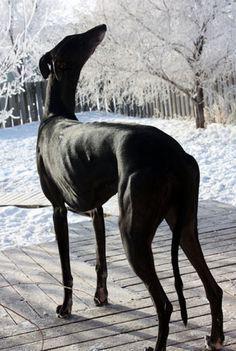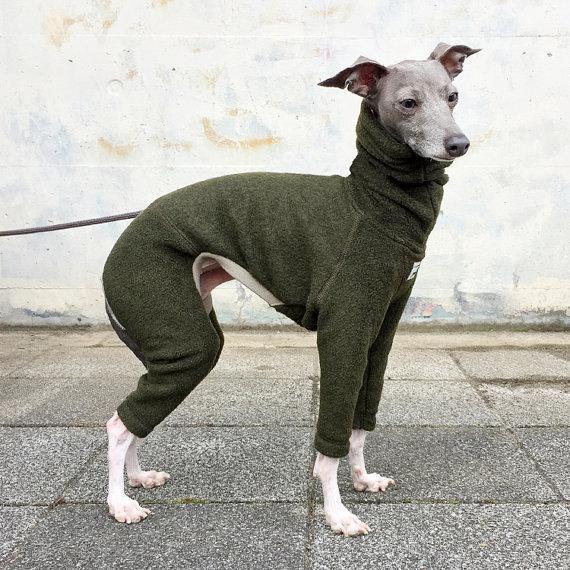The first image is the image on the left, the second image is the image on the right. Examine the images to the left and right. Is the description "An image shows a non-costumed dog with a black face and body, and white paws and chest." accurate? Answer yes or no. No. The first image is the image on the left, the second image is the image on the right. Evaluate the accuracy of this statement regarding the images: "Each Miniature Greyhound dog is standing on all four legs.". Is it true? Answer yes or no. Yes. 